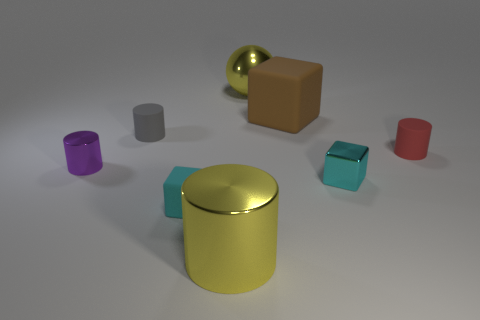Are there any cyan matte objects of the same shape as the purple thing?
Offer a terse response. No. There is a brown object that is the same size as the sphere; what is its material?
Your response must be concise. Rubber. What size is the rubber cylinder that is to the right of the cyan metal thing?
Your response must be concise. Small. There is a matte cylinder to the left of the small red rubber object; is it the same size as the yellow metal thing that is behind the cyan rubber object?
Your answer should be compact. No. What number of big yellow balls are the same material as the gray thing?
Your answer should be very brief. 0. What color is the sphere?
Give a very brief answer. Yellow. Are there any tiny red matte things behind the large yellow ball?
Your answer should be very brief. No. Is the color of the big cylinder the same as the metallic sphere?
Provide a succinct answer. Yes. How many tiny matte cubes have the same color as the big cylinder?
Give a very brief answer. 0. How big is the shiny cylinder that is behind the big yellow thing that is in front of the small gray matte cylinder?
Provide a short and direct response. Small. 